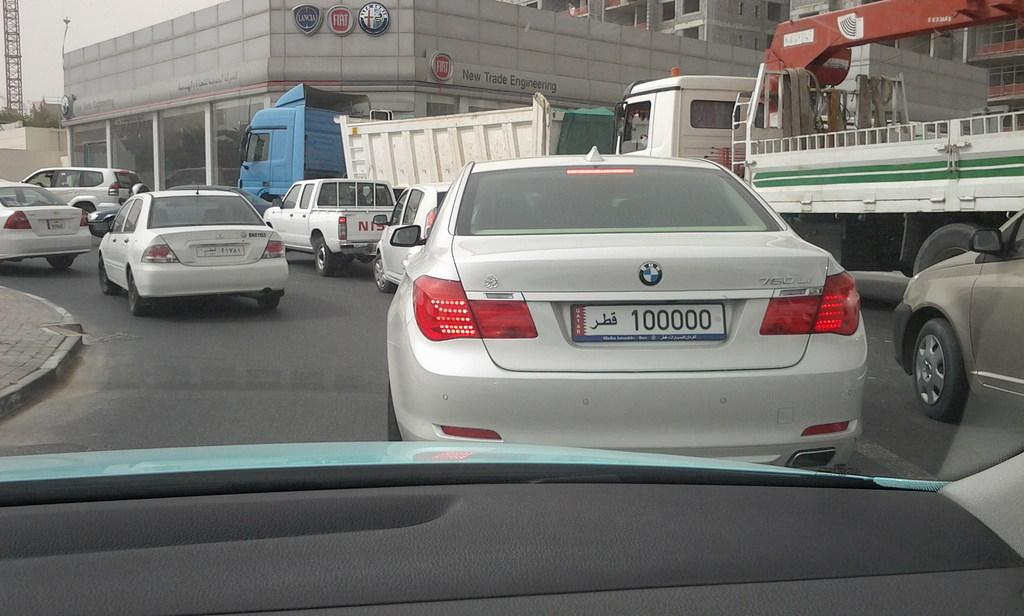<image>
Relay a brief, clear account of the picture shown. A BMW with a license plate that says "100000" is driving in heavy traffic. 